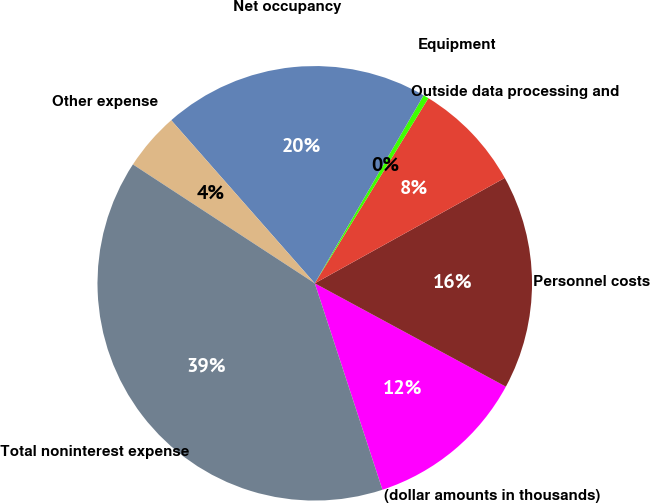Convert chart. <chart><loc_0><loc_0><loc_500><loc_500><pie_chart><fcel>(dollar amounts in thousands)<fcel>Personnel costs<fcel>Outside data processing and<fcel>Equipment<fcel>Net occupancy<fcel>Other expense<fcel>Total noninterest expense<nl><fcel>12.07%<fcel>15.95%<fcel>8.18%<fcel>0.41%<fcel>19.84%<fcel>4.3%<fcel>39.26%<nl></chart> 